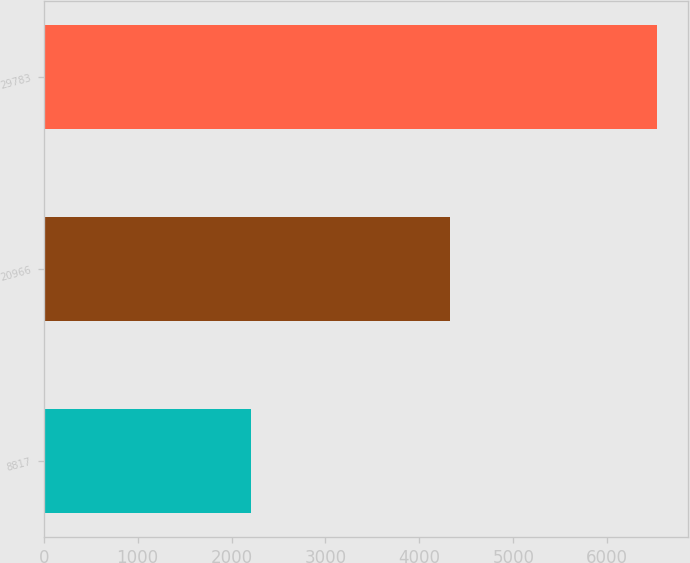<chart> <loc_0><loc_0><loc_500><loc_500><bar_chart><fcel>8817<fcel>20966<fcel>29783<nl><fcel>2204<fcel>4325<fcel>6529<nl></chart> 